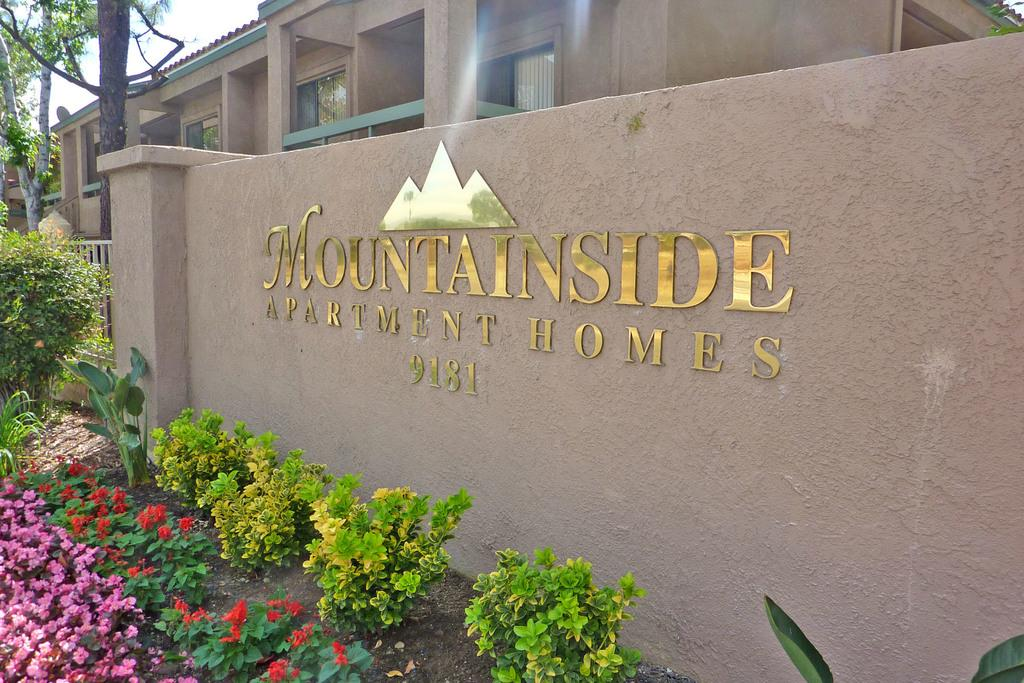What type of vegetation can be seen in the image? There are plants, flowers, and trees in the image. What structure is visible in the background of the image? There is a house in the background of the image. What is the color of the sky in the image? The sky is visible in the background of the image, but the color is not mentioned in the facts. What is the primary feature of the wall in the image? The facts only mention that there is a wall in the image, but not its specific features. Where is the dock located in the image? There is no dock present in the image. What type of brush is used to clean the plants in the image? There is no mention of a brush or any cleaning activity involving the plants in the image. 